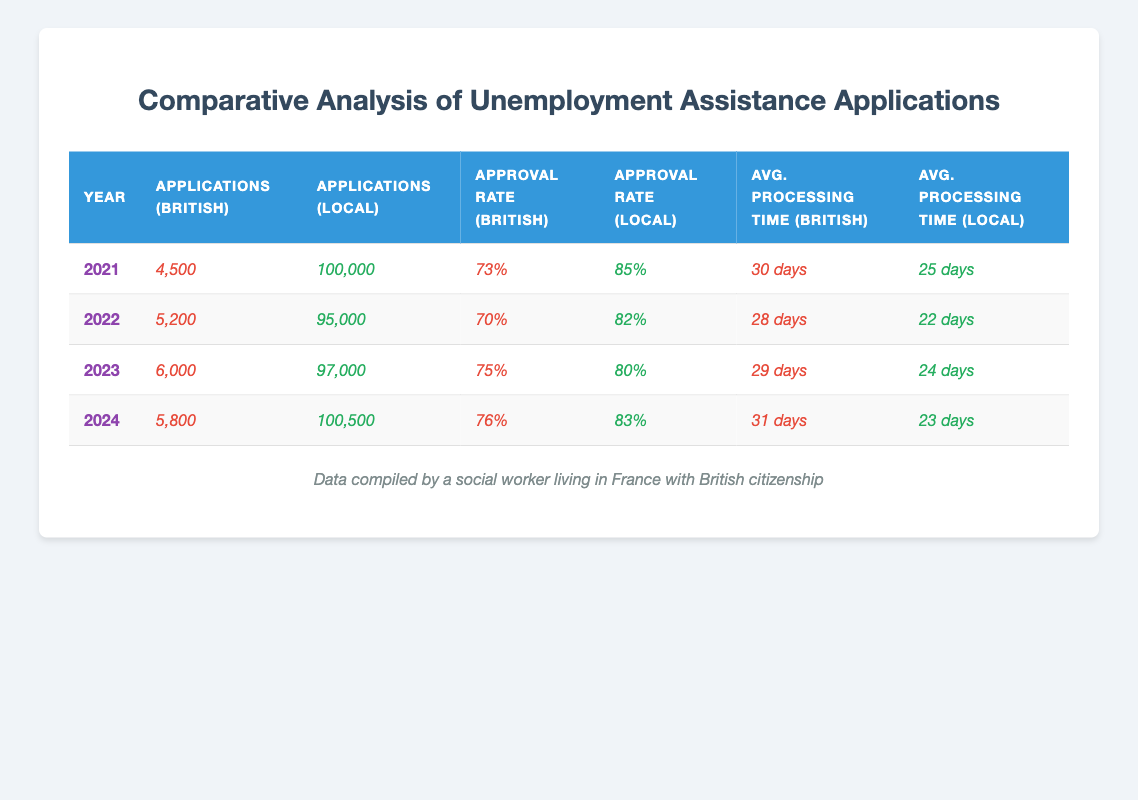What was the approval rate for British citizens in 2023? The table shows the approval rate for British citizens in 2023 is indicated as 75%.
Answer: 75% How many applications did local citizens submit in 2022? According to the table, local citizens submitted 95,000 applications in 2022.
Answer: 95,000 What is the difference in average processing time between British and local citizens in 2021? In 2021, British citizens had an average processing time of 30 days while local citizens had 25 days. The difference is 30 - 25 = 5 days.
Answer: 5 days What was the trend in the number of applications from British citizens from 2021 to 2024? Looking at the years 2021 (4,500), 2022 (5,200), 2023 (6,000), and 2024 (5,800), the number of applications increased from 2021 to 2023, then decreased slightly in 2024.
Answer: Increased then slightly decreased Did the approval rate for local citizens improve from 2021 to 2024? The approval rate for local citizens was 85% in 2021 and reduced to 83% in 2024, indicating a decrease.
Answer: No What was the average approval rate for British citizens from 2021 to 2024? The approval rates for British citizens are 73%, 70%, 75%, and 76%. To find the average, sum them: 73 + 70 + 75 + 76 = 294, then divide by 4: 294 / 4 = 73.5%.
Answer: 73.5% What year had the least number of applications from British citizens compared to local citizens? The year 2021 had the least applications from British citizens at 4,500 compared to 100,000 local citizens.
Answer: 2021 Which year had the highest approval rate for British citizens? The year 2024 has the highest approval rate for British citizens at 76%.
Answer: 2024 What was the trend of applications from local citizens from 2021 to 2024? The applications from local citizens were 100,000 in 2021, decreased to 95,000 in 2022, increased to 97,000 in 2023, then rose to 100,500 in 2024. Thus, the trend shows fluctuations but ends higher than 2021.
Answer: Fluctuating upward trend In which year did British citizens have the shortest average processing time? In 2022, British citizens had the shortest average processing time of 28 days.
Answer: 2022 How many more applications did local citizens submit than British citizens in 2023? In 2023, local citizens submitted 97,000 applications while British citizens submitted 6,000. The difference is 97,000 - 6,000 = 91,000 applications.
Answer: 91,000 